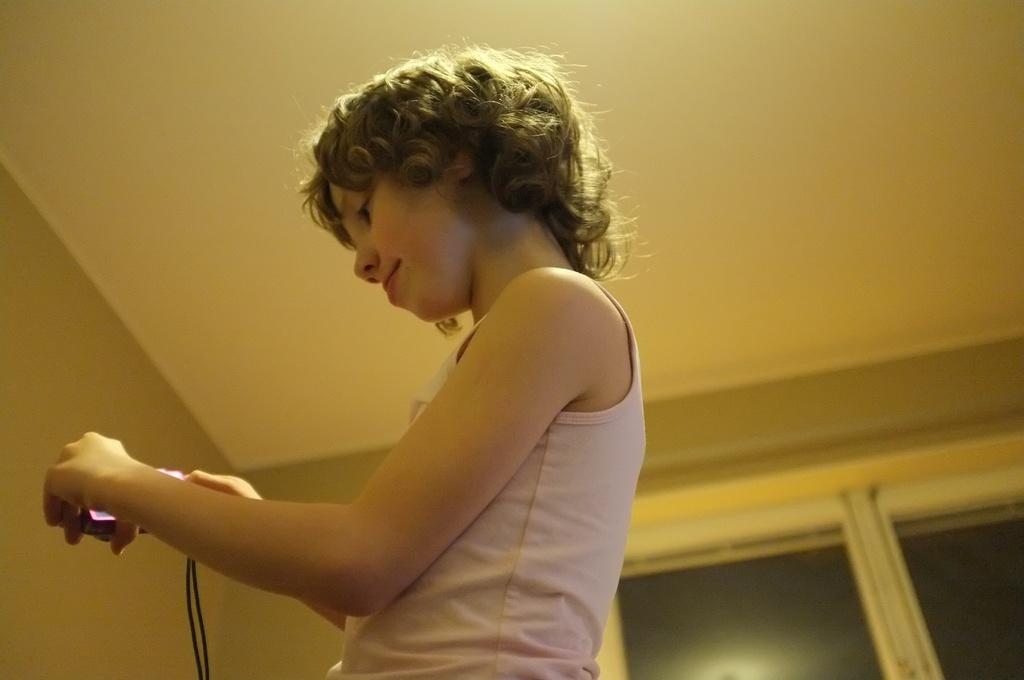Please provide a concise description of this image. In this is a small girl wearing a white color top and holding a phone in the hand and looking to it. Behind there is a white glass window and brown walls. 